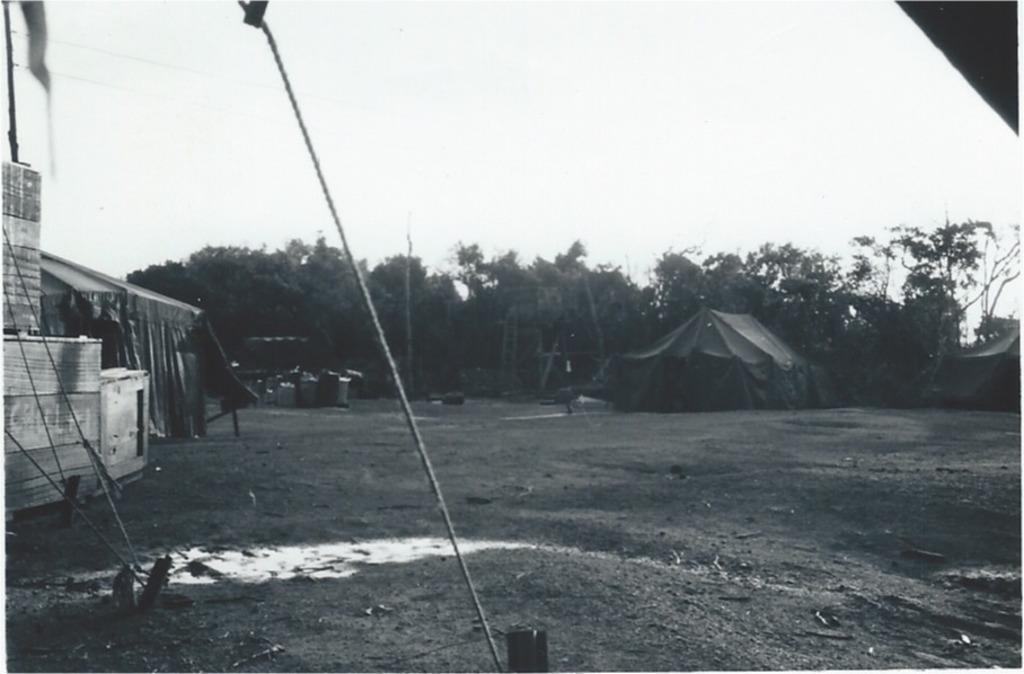Please provide a concise description of this image. In this image we can see the tents for shelter. We can also see the trees, ropes and also the house on the left. At the top we can see the sky and at the bottom we can see the soil land. 